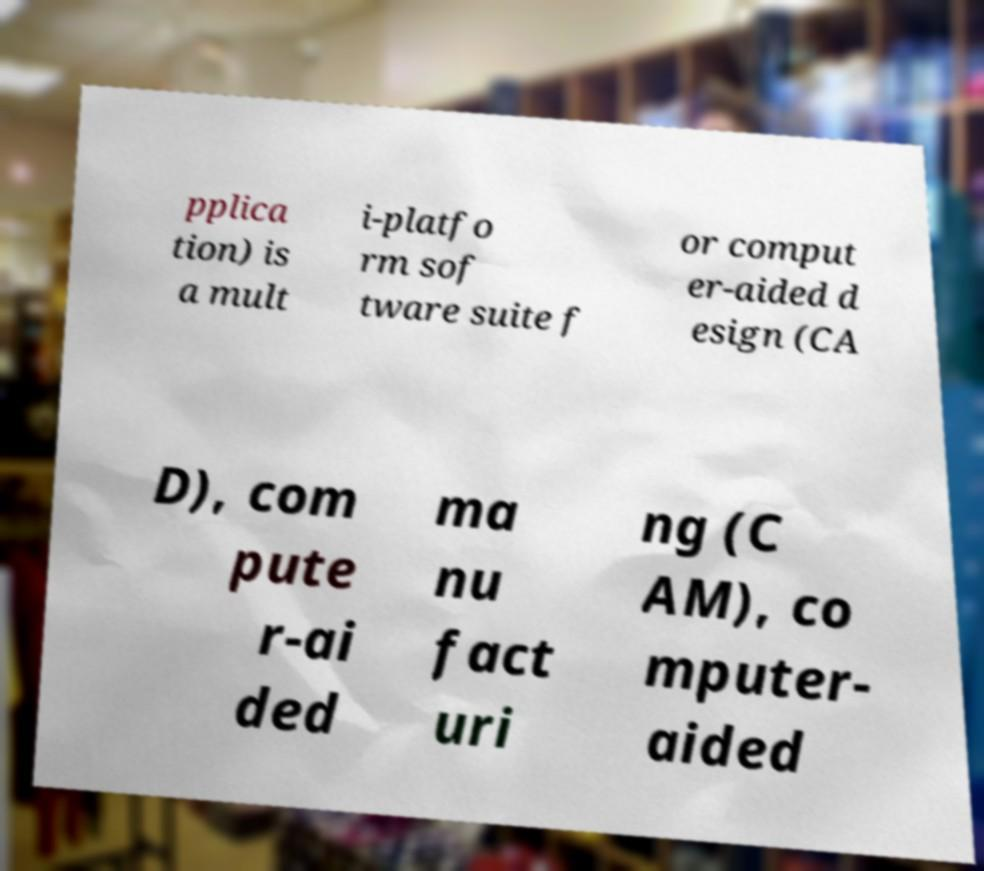Could you assist in decoding the text presented in this image and type it out clearly? pplica tion) is a mult i-platfo rm sof tware suite f or comput er-aided d esign (CA D), com pute r-ai ded ma nu fact uri ng (C AM), co mputer- aided 